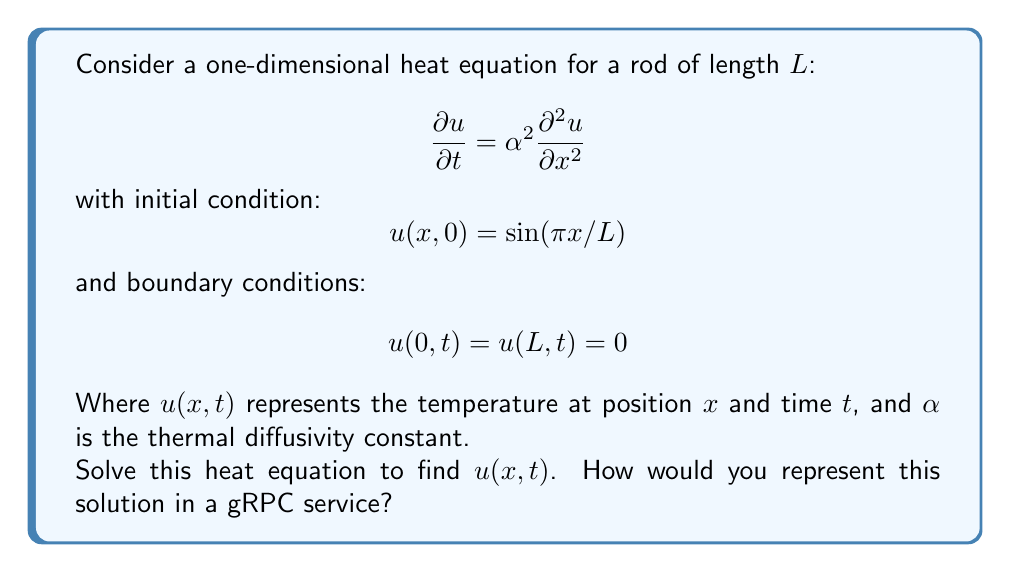Solve this math problem. To solve this heat equation, we'll use the method of separation of variables:

1) Assume the solution has the form: $u(x,t) = X(x)T(t)$

2) Substituting this into the heat equation:
   $$X(x)T'(t) = \alpha^2 X''(x)T(t)$$

3) Separating variables:
   $$\frac{T'(t)}{T(t)} = \alpha^2 \frac{X''(x)}{X(x)} = -\lambda$$

4) This gives us two ODEs:
   $$T'(t) + \lambda \alpha^2 T(t) = 0$$
   $$X''(x) + \lambda X(x) = 0$$

5) The boundary conditions imply:
   $$X(0) = X(L) = 0$$
   This eigenvalue problem has solutions:
   $$X_n(x) = \sin(n\pi x/L), \lambda_n = (n\pi/L)^2, n = 1,2,3,...$$

6) Solving for $T(t)$:
   $$T_n(t) = e^{-\alpha^2 (n\pi/L)^2 t}$$

7) The general solution is:
   $$u(x,t) = \sum_{n=1}^{\infty} A_n \sin(n\pi x/L) e^{-\alpha^2 (n\pi/L)^2 t}$$

8) Using the initial condition:
   $$\sin(\pi x/L) = \sum_{n=1}^{\infty} A_n \sin(n\pi x/L)$$

9) This implies $A_1 = 1$ and $A_n = 0$ for $n > 1$

Therefore, the solution is:
$$u(x,t) = \sin(\pi x/L) e^{-\alpha^2 (\pi/L)^2 t}$$

To represent this in a gRPC service:
1) Define a message type for input parameters (L, α, x, t)
2) Define a message type for the output (temperature u)
3) Create a service with a method that takes the input message and returns the output message
4) Implement the server to calculate u using the derived formula
5) Implement a client to send requests and receive responses
Answer: $u(x,t) = \sin(\pi x/L) e^{-\alpha^2 (\pi/L)^2 t}$ 